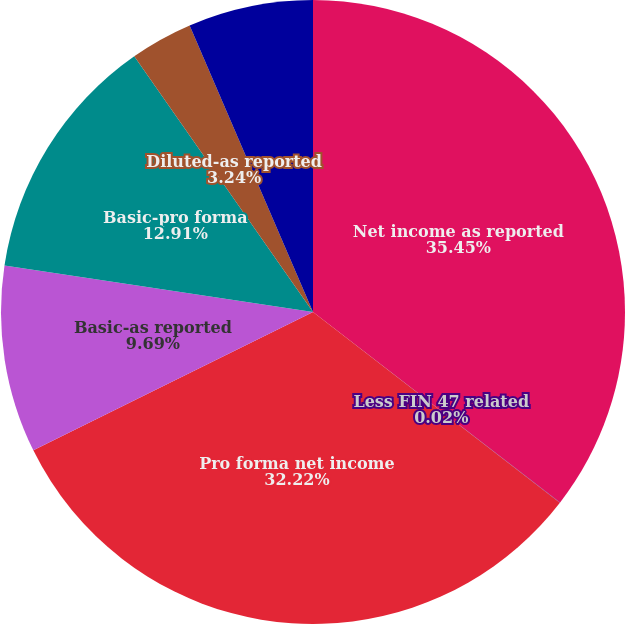<chart> <loc_0><loc_0><loc_500><loc_500><pie_chart><fcel>Net income as reported<fcel>Less FIN 47 related<fcel>Pro forma net income<fcel>Basic-as reported<fcel>Basic-pro forma<fcel>Diluted-as reported<fcel>Diluted-pro forma<nl><fcel>35.45%<fcel>0.02%<fcel>32.22%<fcel>9.69%<fcel>12.91%<fcel>3.24%<fcel>6.47%<nl></chart> 